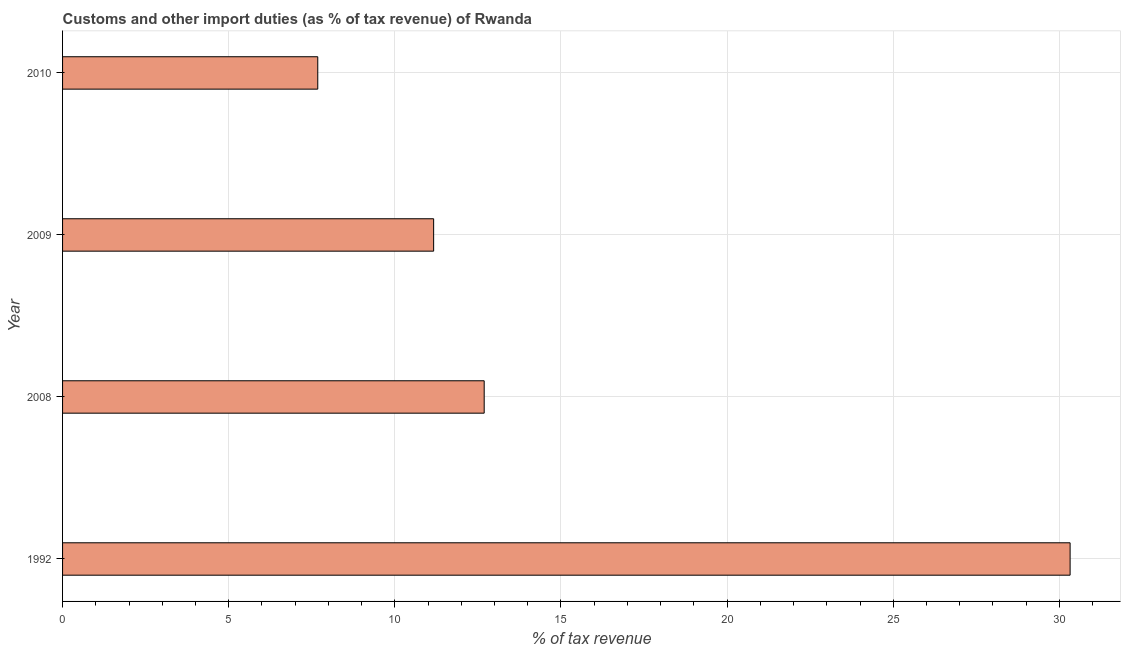What is the title of the graph?
Offer a very short reply. Customs and other import duties (as % of tax revenue) of Rwanda. What is the label or title of the X-axis?
Make the answer very short. % of tax revenue. What is the customs and other import duties in 2009?
Provide a succinct answer. 11.17. Across all years, what is the maximum customs and other import duties?
Provide a short and direct response. 30.32. Across all years, what is the minimum customs and other import duties?
Your answer should be compact. 7.68. In which year was the customs and other import duties maximum?
Give a very brief answer. 1992. What is the sum of the customs and other import duties?
Keep it short and to the point. 61.86. What is the difference between the customs and other import duties in 2008 and 2010?
Make the answer very short. 5.01. What is the average customs and other import duties per year?
Your response must be concise. 15.46. What is the median customs and other import duties?
Your answer should be compact. 11.93. In how many years, is the customs and other import duties greater than 1 %?
Give a very brief answer. 4. Do a majority of the years between 2008 and 2010 (inclusive) have customs and other import duties greater than 15 %?
Your response must be concise. No. What is the ratio of the customs and other import duties in 2008 to that in 2009?
Offer a very short reply. 1.14. What is the difference between the highest and the second highest customs and other import duties?
Give a very brief answer. 17.63. Is the sum of the customs and other import duties in 2008 and 2009 greater than the maximum customs and other import duties across all years?
Your answer should be compact. No. What is the difference between the highest and the lowest customs and other import duties?
Offer a terse response. 22.64. In how many years, is the customs and other import duties greater than the average customs and other import duties taken over all years?
Offer a very short reply. 1. Are all the bars in the graph horizontal?
Ensure brevity in your answer.  Yes. What is the difference between two consecutive major ticks on the X-axis?
Your answer should be very brief. 5. What is the % of tax revenue in 1992?
Your answer should be very brief. 30.32. What is the % of tax revenue of 2008?
Your answer should be compact. 12.69. What is the % of tax revenue in 2009?
Your answer should be very brief. 11.17. What is the % of tax revenue in 2010?
Your answer should be very brief. 7.68. What is the difference between the % of tax revenue in 1992 and 2008?
Give a very brief answer. 17.63. What is the difference between the % of tax revenue in 1992 and 2009?
Your answer should be very brief. 19.16. What is the difference between the % of tax revenue in 1992 and 2010?
Offer a very short reply. 22.64. What is the difference between the % of tax revenue in 2008 and 2009?
Your response must be concise. 1.52. What is the difference between the % of tax revenue in 2008 and 2010?
Give a very brief answer. 5.01. What is the difference between the % of tax revenue in 2009 and 2010?
Your answer should be very brief. 3.49. What is the ratio of the % of tax revenue in 1992 to that in 2008?
Give a very brief answer. 2.39. What is the ratio of the % of tax revenue in 1992 to that in 2009?
Keep it short and to the point. 2.71. What is the ratio of the % of tax revenue in 1992 to that in 2010?
Keep it short and to the point. 3.95. What is the ratio of the % of tax revenue in 2008 to that in 2009?
Your answer should be compact. 1.14. What is the ratio of the % of tax revenue in 2008 to that in 2010?
Keep it short and to the point. 1.65. What is the ratio of the % of tax revenue in 2009 to that in 2010?
Provide a succinct answer. 1.45. 